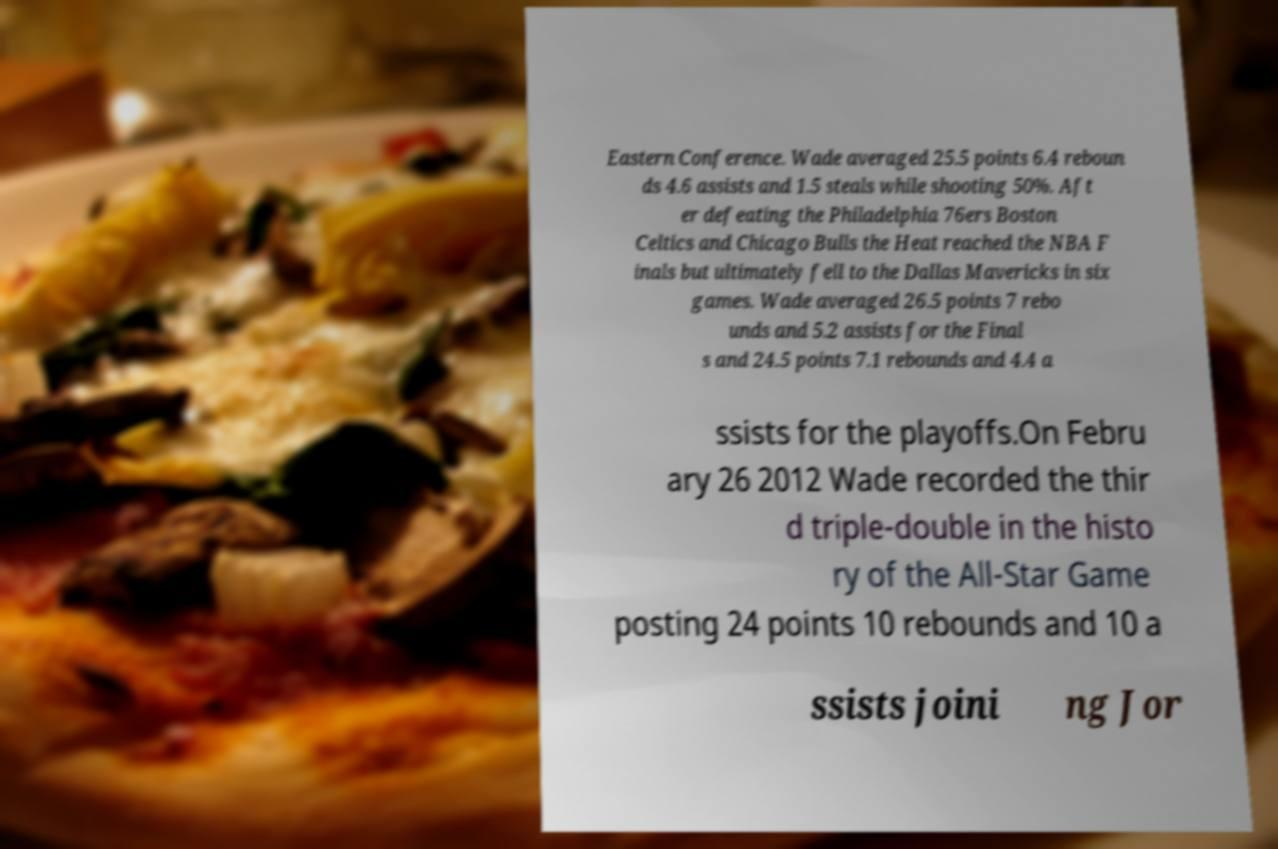I need the written content from this picture converted into text. Can you do that? Eastern Conference. Wade averaged 25.5 points 6.4 reboun ds 4.6 assists and 1.5 steals while shooting 50%. Aft er defeating the Philadelphia 76ers Boston Celtics and Chicago Bulls the Heat reached the NBA F inals but ultimately fell to the Dallas Mavericks in six games. Wade averaged 26.5 points 7 rebo unds and 5.2 assists for the Final s and 24.5 points 7.1 rebounds and 4.4 a ssists for the playoffs.On Febru ary 26 2012 Wade recorded the thir d triple-double in the histo ry of the All-Star Game posting 24 points 10 rebounds and 10 a ssists joini ng Jor 